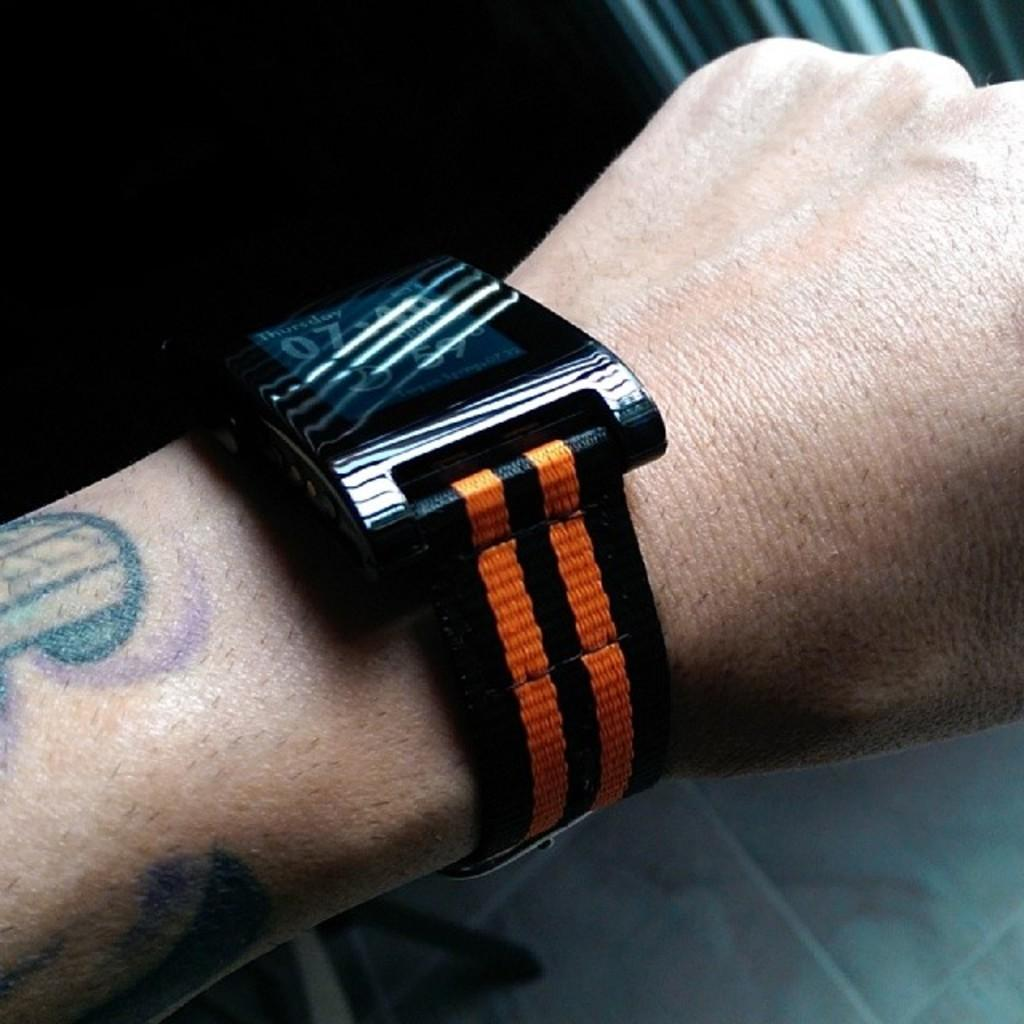<image>
Render a clear and concise summary of the photo. A watch with a back and orange band displays Thursday and 59 degrees. 